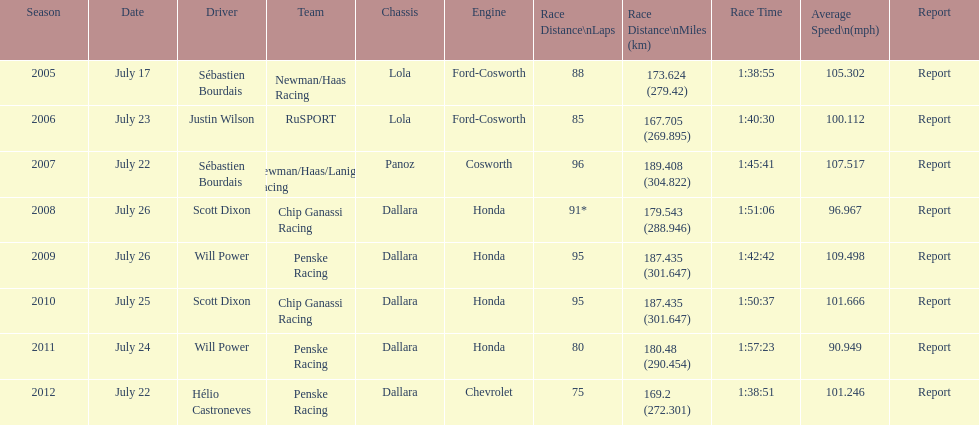How many different teams are represented in the table? 4. 